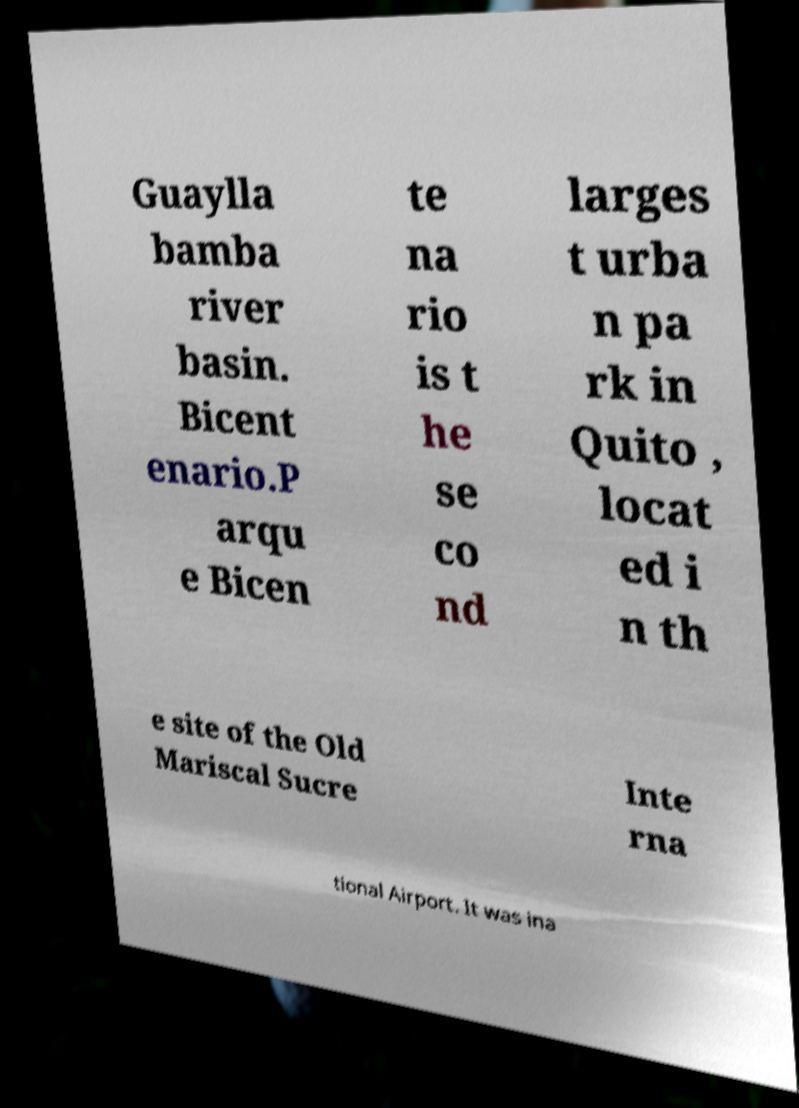I need the written content from this picture converted into text. Can you do that? Guaylla bamba river basin. Bicent enario.P arqu e Bicen te na rio is t he se co nd larges t urba n pa rk in Quito , locat ed i n th e site of the Old Mariscal Sucre Inte rna tional Airport. It was ina 